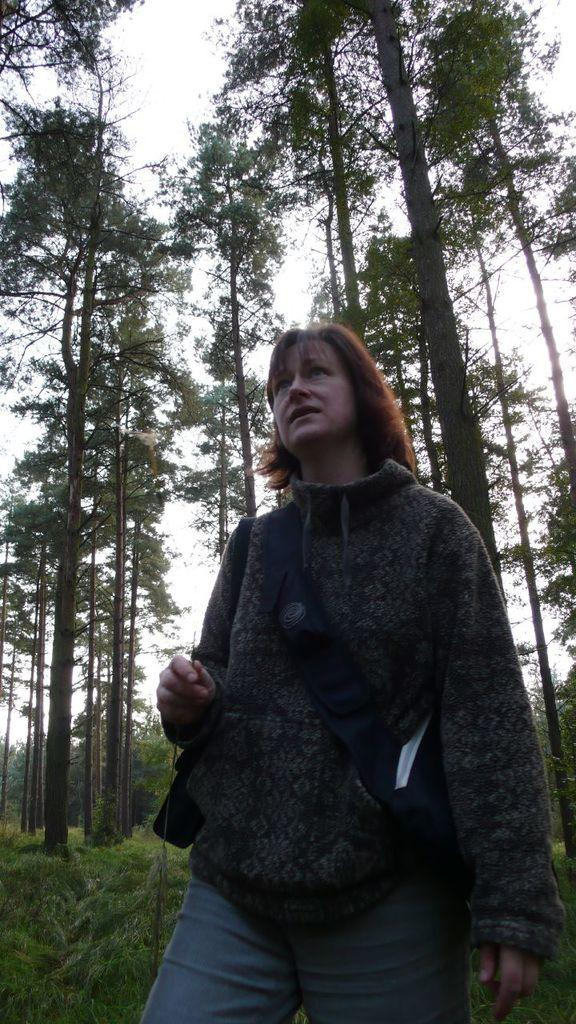Who is the main subject in the picture? There is a woman in the middle of the picture. What is the woman wearing? The woman is wearing a black jacket and blue jeans. What is the woman's posture in the picture? The woman is standing. What can be seen in the background of the picture? There are many trees behind the woman. What is visible at the top of the picture? The sky is visible at the top of the picture. How many caves are visible in the picture? There are no caves present in the image. 